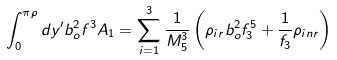Convert formula to latex. <formula><loc_0><loc_0><loc_500><loc_500>\int _ { 0 } ^ { \pi \rho } d y ^ { \prime } b _ { o } ^ { 2 } f ^ { 3 } A _ { 1 } = \sum _ { i = 1 } ^ { 3 } \frac { 1 } { M _ { 5 } ^ { 3 } } \left ( \rho _ { i r } b _ { o } ^ { 2 } f _ { 3 } ^ { 5 } + \frac { 1 } { f _ { 3 } } \rho _ { i n r } \right )</formula> 